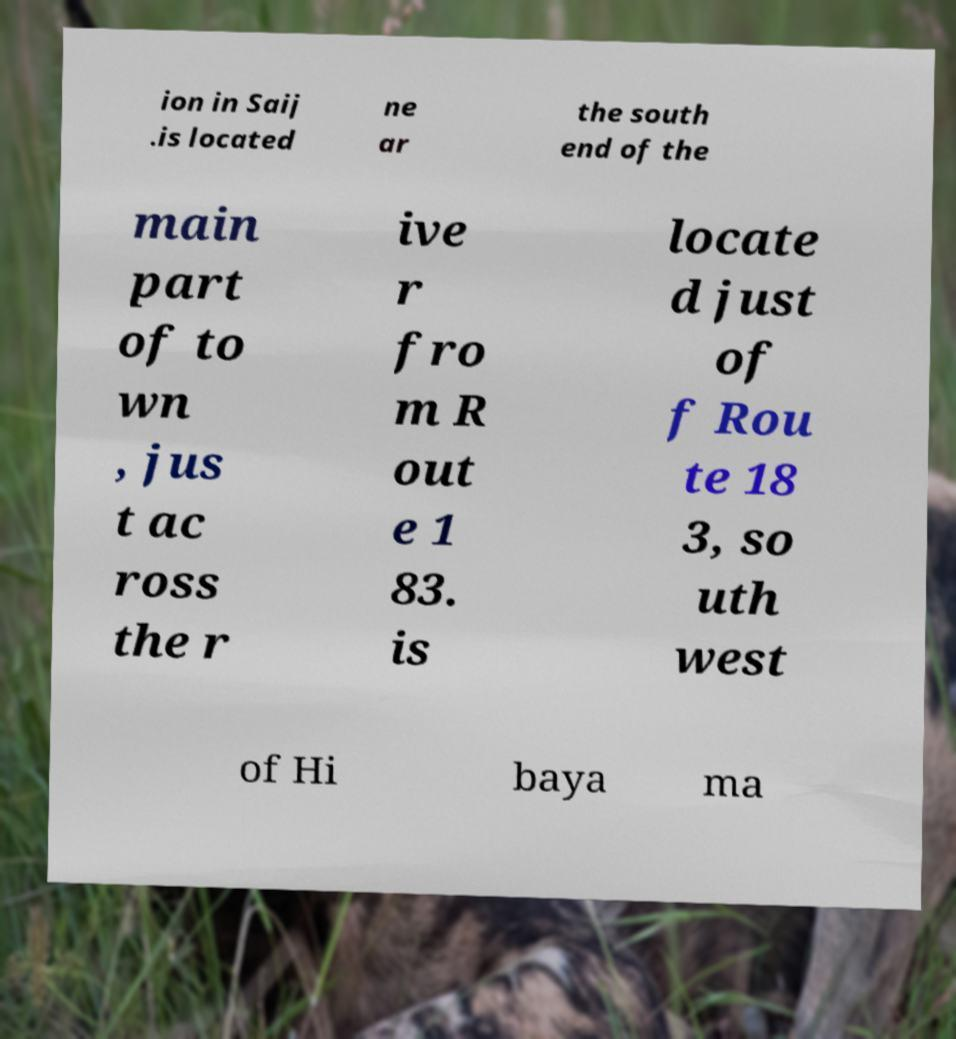What messages or text are displayed in this image? I need them in a readable, typed format. ion in Saij .is located ne ar the south end of the main part of to wn , jus t ac ross the r ive r fro m R out e 1 83. is locate d just of f Rou te 18 3, so uth west of Hi baya ma 